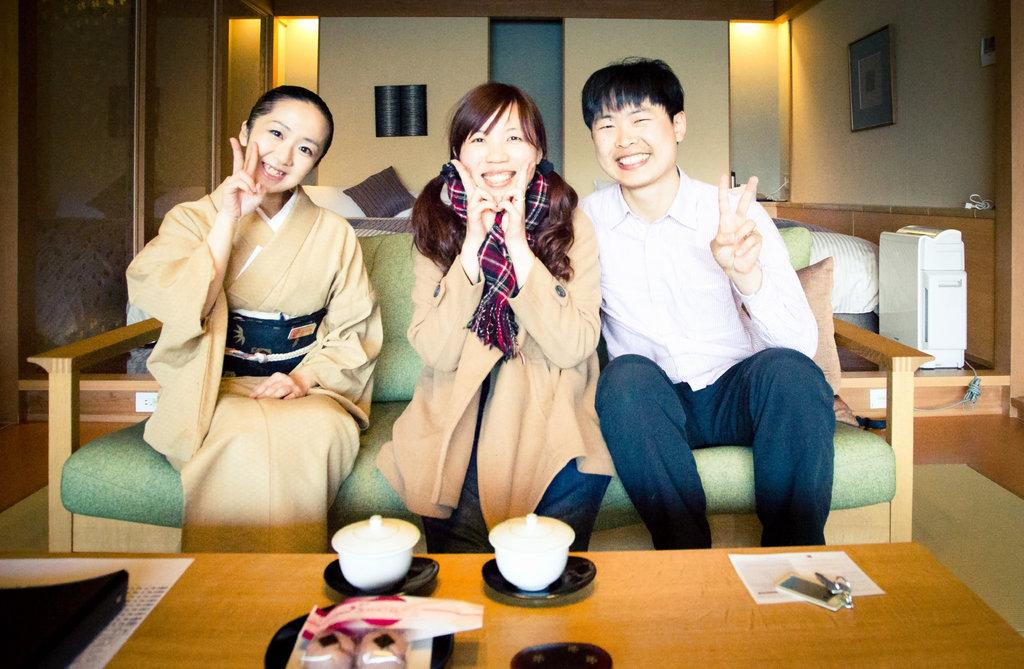How many people are sitting on the sofa in the image? There are 3 people sitting on the sofa in the image. What is located in front of the sofa? There is a table in front of the sofa. What items can be seen on the table? There are papers and keys on the table. What is hanging on the wall behind the sofa? There is a photo frame on the wall behind the sofa. What type of vegetable is being used as a decoration on the sofa? There are no vegetables present in the image, and the sofa is not being used as a decoration. How many trucks can be seen driving past the window in the image? There is no window or trucks visible in the image. 